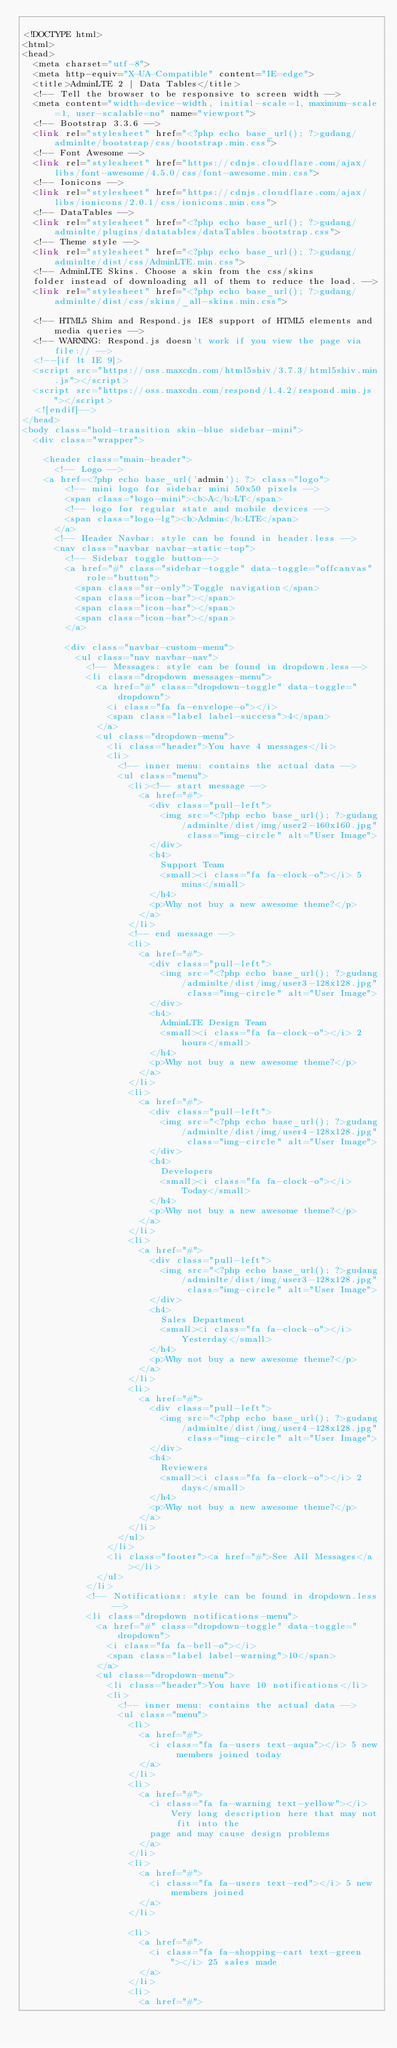<code> <loc_0><loc_0><loc_500><loc_500><_PHP_>
<!DOCTYPE html>
<html>
<head>
  <meta charset="utf-8">
  <meta http-equiv="X-UA-Compatible" content="IE=edge">
  <title>AdminLTE 2 | Data Tables</title>
  <!-- Tell the browser to be responsive to screen width -->
  <meta content="width=device-width, initial-scale=1, maximum-scale=1, user-scalable=no" name="viewport">
  <!-- Bootstrap 3.3.6 -->
  <link rel="stylesheet" href="<?php echo base_url(); ?>gudang/adminlte/bootstrap/css/bootstrap.min.css">
  <!-- Font Awesome -->
  <link rel="stylesheet" href="https://cdnjs.cloudflare.com/ajax/libs/font-awesome/4.5.0/css/font-awesome.min.css">
  <!-- Ionicons -->
  <link rel="stylesheet" href="https://cdnjs.cloudflare.com/ajax/libs/ionicons/2.0.1/css/ionicons.min.css">
  <!-- DataTables -->
  <link rel="stylesheet" href="<?php echo base_url(); ?>gudang/adminlte/plugins/datatables/dataTables.bootstrap.css">
  <!-- Theme style -->
  <link rel="stylesheet" href="<?php echo base_url(); ?>gudang/adminlte/dist/css/AdminLTE.min.css">
  <!-- AdminLTE Skins. Choose a skin from the css/skins
  folder instead of downloading all of them to reduce the load. -->
  <link rel="stylesheet" href="<?php echo base_url(); ?>gudang/adminlte/dist/css/skins/_all-skins.min.css">

  <!-- HTML5 Shim and Respond.js IE8 support of HTML5 elements and media queries -->
  <!-- WARNING: Respond.js doesn't work if you view the page via file:// -->
  <!--[if lt IE 9]>
  <script src="https://oss.maxcdn.com/html5shiv/3.7.3/html5shiv.min.js"></script>
  <script src="https://oss.maxcdn.com/respond/1.4.2/respond.min.js"></script>
  <![endif]-->
</head>
<body class="hold-transition skin-blue sidebar-mini">
  <div class="wrapper">

    <header class="main-header">
      <!-- Logo -->
    <a href=<?php echo base_url('admin'); ?> class="logo">
        <!-- mini logo for sidebar mini 50x50 pixels -->
        <span class="logo-mini"><b>A</b>LT</span>
        <!-- logo for regular state and mobile devices -->
        <span class="logo-lg"><b>Admin</b>LTE</span>
      </a>
      <!-- Header Navbar: style can be found in header.less -->
      <nav class="navbar navbar-static-top">
        <!-- Sidebar toggle button-->
        <a href="#" class="sidebar-toggle" data-toggle="offcanvas" role="button">
          <span class="sr-only">Toggle navigation</span>
          <span class="icon-bar"></span>
          <span class="icon-bar"></span>
          <span class="icon-bar"></span>
        </a>

        <div class="navbar-custom-menu">
          <ul class="nav navbar-nav">
            <!-- Messages: style can be found in dropdown.less-->
            <li class="dropdown messages-menu">
              <a href="#" class="dropdown-toggle" data-toggle="dropdown">
                <i class="fa fa-envelope-o"></i>
                <span class="label label-success">4</span>
              </a>
              <ul class="dropdown-menu">
                <li class="header">You have 4 messages</li>
                <li>
                  <!-- inner menu: contains the actual data -->
                  <ul class="menu">
                    <li><!-- start message -->
                      <a href="#">
                        <div class="pull-left">
                          <img src="<?php echo base_url(); ?>gudang/adminlte/dist/img/user2-160x160.jpg" class="img-circle" alt="User Image">
                        </div>
                        <h4>
                          Support Team
                          <small><i class="fa fa-clock-o"></i> 5 mins</small>
                        </h4>
                        <p>Why not buy a new awesome theme?</p>
                      </a>
                    </li>
                    <!-- end message -->
                    <li>
                      <a href="#">
                        <div class="pull-left">
                          <img src="<?php echo base_url(); ?>gudang/adminlte/dist/img/user3-128x128.jpg" class="img-circle" alt="User Image">
                        </div>
                        <h4>
                          AdminLTE Design Team
                          <small><i class="fa fa-clock-o"></i> 2 hours</small>
                        </h4>
                        <p>Why not buy a new awesome theme?</p>
                      </a>
                    </li>
                    <li>
                      <a href="#">
                        <div class="pull-left">
                          <img src="<?php echo base_url(); ?>gudang/adminlte/dist/img/user4-128x128.jpg" class="img-circle" alt="User Image">
                        </div>
                        <h4>
                          Developers
                          <small><i class="fa fa-clock-o"></i> Today</small>
                        </h4>
                        <p>Why not buy a new awesome theme?</p>
                      </a>
                    </li>
                    <li>
                      <a href="#">
                        <div class="pull-left">
                          <img src="<?php echo base_url(); ?>gudang/adminlte/dist/img/user3-128x128.jpg" class="img-circle" alt="User Image">
                        </div>
                        <h4>
                          Sales Department
                          <small><i class="fa fa-clock-o"></i> Yesterday</small>
                        </h4>
                        <p>Why not buy a new awesome theme?</p>
                      </a>
                    </li>
                    <li>
                      <a href="#">
                        <div class="pull-left">
                          <img src="<?php echo base_url(); ?>gudang/adminlte/dist/img/user4-128x128.jpg" class="img-circle" alt="User Image">
                        </div>
                        <h4>
                          Reviewers
                          <small><i class="fa fa-clock-o"></i> 2 days</small>
                        </h4>
                        <p>Why not buy a new awesome theme?</p>
                      </a>
                    </li>
                  </ul>
                </li>
                <li class="footer"><a href="#">See All Messages</a></li>
              </ul>
            </li>
            <!-- Notifications: style can be found in dropdown.less -->
            <li class="dropdown notifications-menu">
              <a href="#" class="dropdown-toggle" data-toggle="dropdown">
                <i class="fa fa-bell-o"></i>
                <span class="label label-warning">10</span>
              </a>
              <ul class="dropdown-menu">
                <li class="header">You have 10 notifications</li>
                <li>
                  <!-- inner menu: contains the actual data -->
                  <ul class="menu">
                    <li>
                      <a href="#">
                        <i class="fa fa-users text-aqua"></i> 5 new members joined today
                      </a>
                    </li>
                    <li>
                      <a href="#">
                        <i class="fa fa-warning text-yellow"></i> Very long description here that may not fit into the
                        page and may cause design problems
                      </a>
                    </li>
                    <li>
                      <a href="#">
                        <i class="fa fa-users text-red"></i> 5 new members joined
                      </a>
                    </li>

                    <li>
                      <a href="#">
                        <i class="fa fa-shopping-cart text-green"></i> 25 sales made
                      </a>
                    </li>
                    <li>
                      <a href="#"></code> 